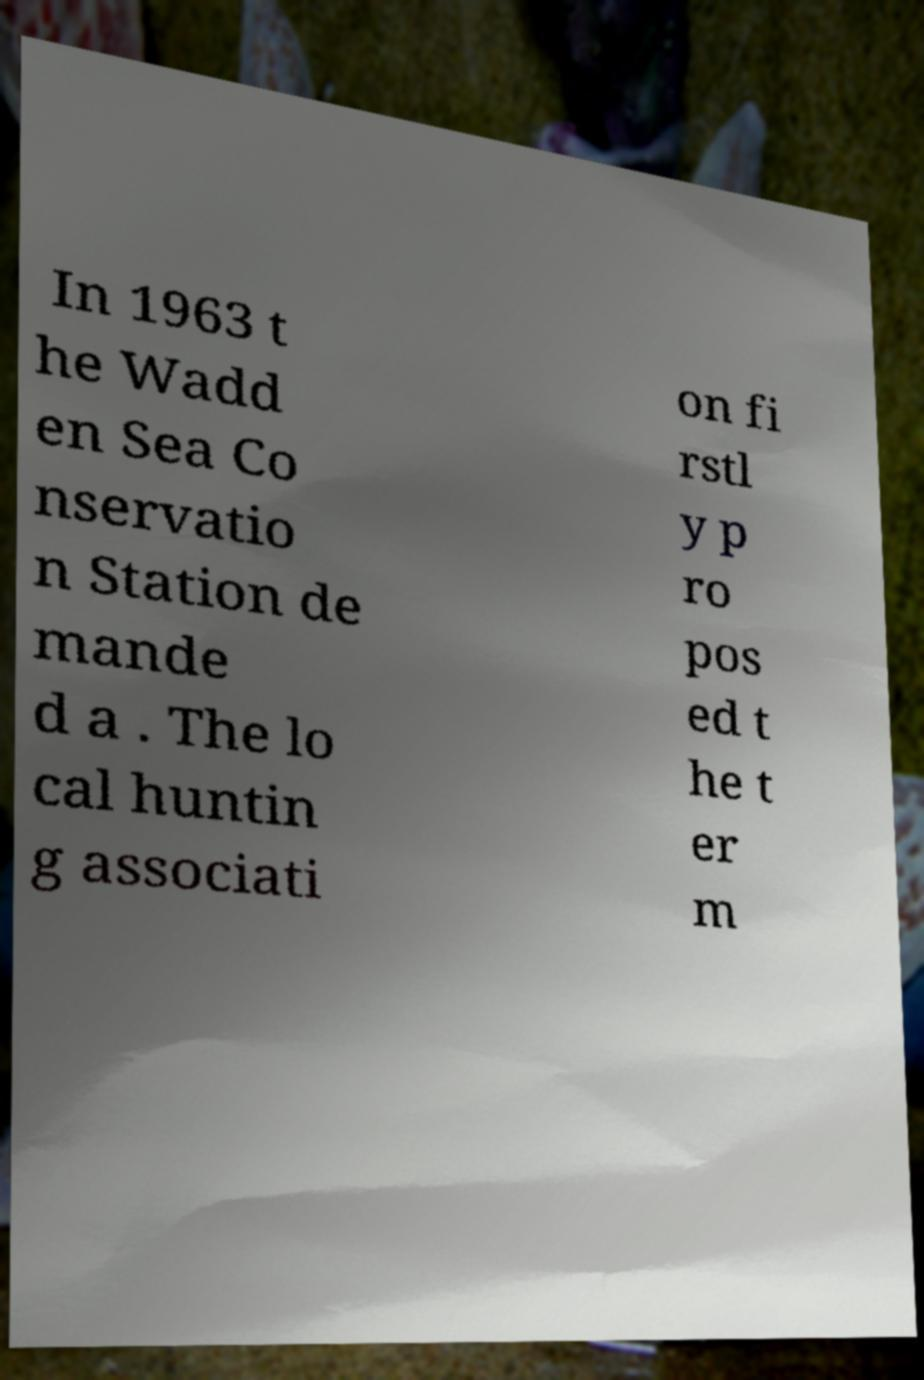For documentation purposes, I need the text within this image transcribed. Could you provide that? In 1963 t he Wadd en Sea Co nservatio n Station de mande d a . The lo cal huntin g associati on fi rstl y p ro pos ed t he t er m 